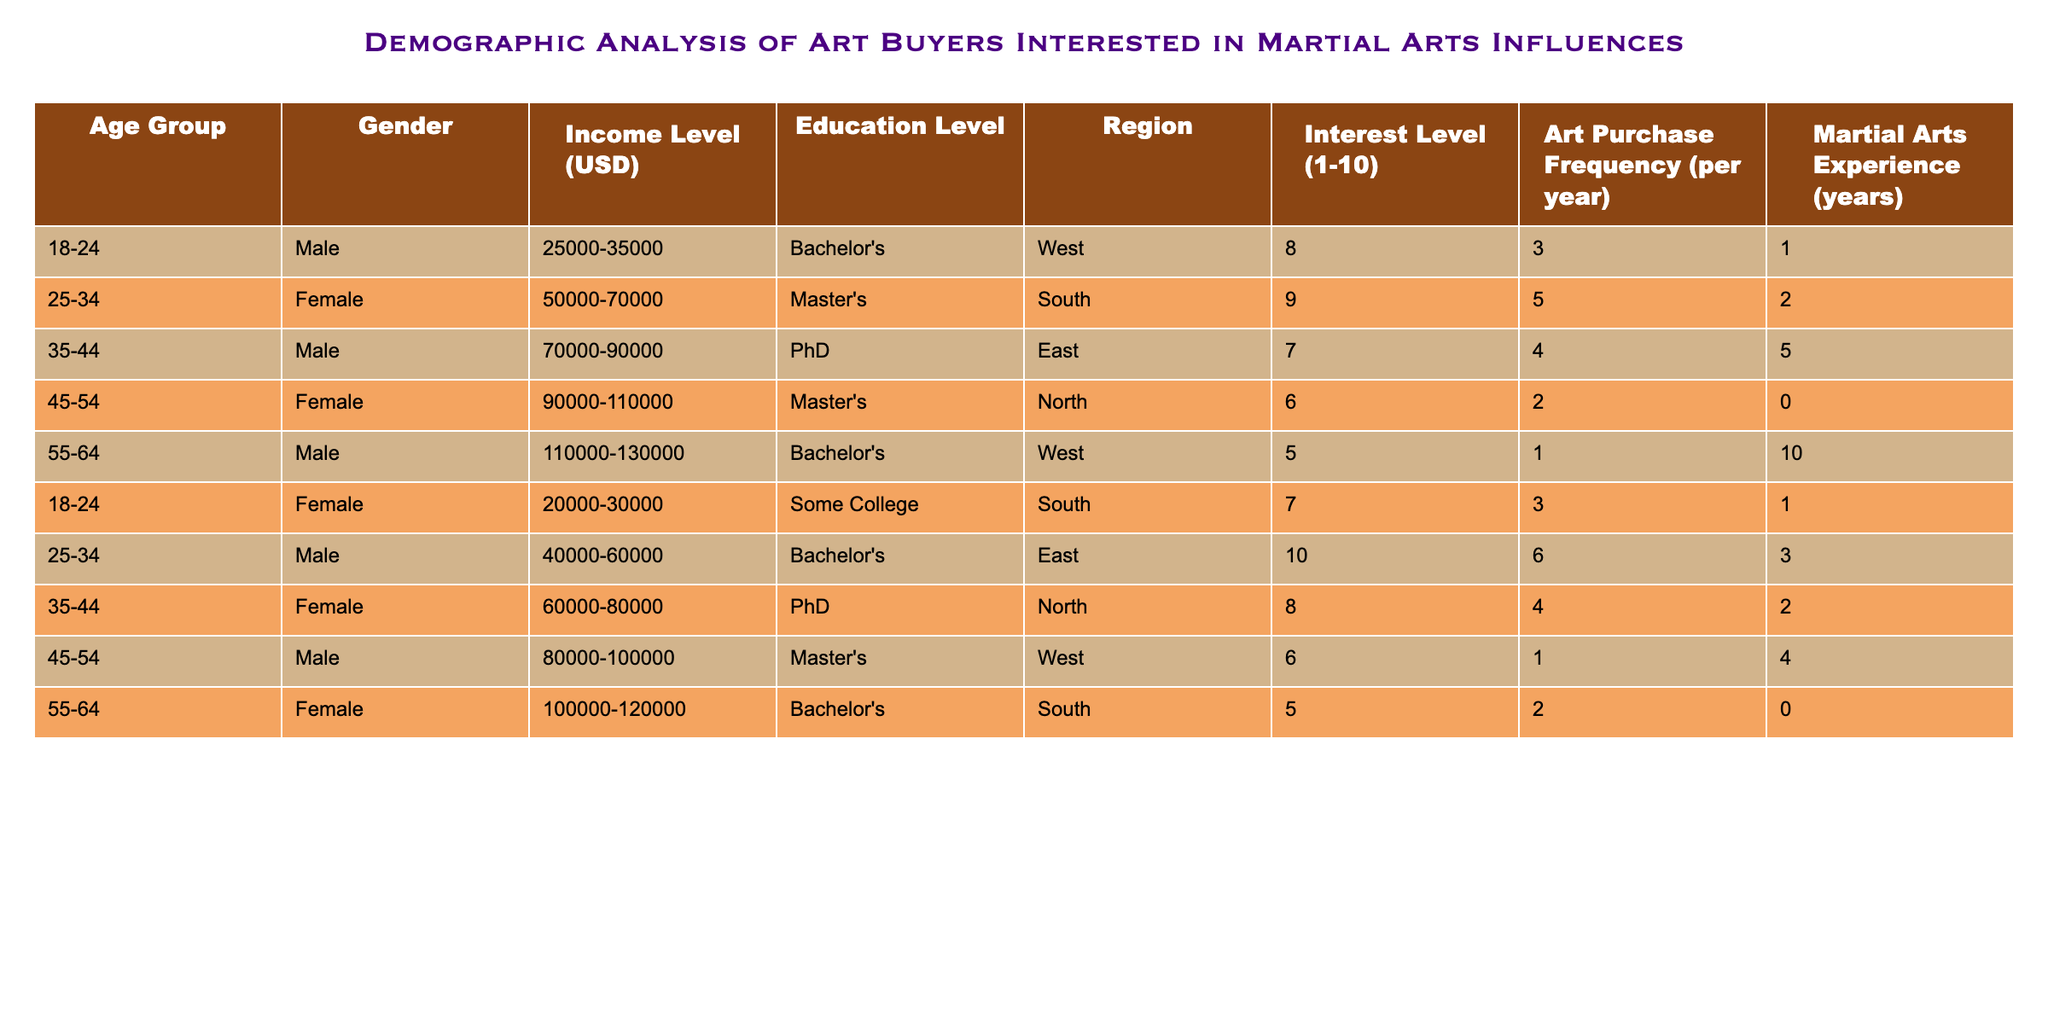What is the most common income level among art buyers? The income levels in the table show that there are several distinct ranges. By counting the occurrences of each income range, the most common one is 50000-70000, which appears twice among the art buyers.
Answer: 50000-70000 How many buyers have a martial arts experience of 2 years? By scanning the table, I identify individuals with 2 years of martial arts experience. There is one male in the age group 35-44 and one female in the age group 25-34, totaling two buyers.
Answer: 2 What is the average interest level of male art buyers? To calculate the average interest level of male buyers, first, identify all the male interest levels: 8, 7, 5, 10, and 6. The total is 36 (8+7+5+10+6) and there are 5 male buyers. Thus, the average is 36/5, which equals 7.2.
Answer: 7.2 Are there any female buyers with a PhD who have purchased art more than 4 times a year? Checking the table, I find two female buyers with PhD: one aged 35-44 (4 purchases) and the other aged 25-34 (5 purchases). None of them exceed 4 purchases. Therefore, the answer is no.
Answer: No Which age group has the highest average art purchase frequency? First, I need to calculate the average for each age group: 18-24 has averages of 3 and 3 (average = 3), 25-34 averages of 5 and 6 (average = 5.5), 35-44 averages of 4 and 4 (average = 4), 45-54 averages of 2 and 1 (average = 1.5), and 55-64 averages of 1 and 2 (average = 1.5). The highest average is from the 25-34 age group at 5.5.
Answer: 25-34 What percentage of buyers from the West region are interested at a level of 8 or higher? In the West region, there are 3 buyers: one male aged 55-64 with an interest level of 5, and two females aged 18-24 and 45-54 with interest levels of 8 and 6 respectively. Only the female aged 18-24 is at an interest level of 8 or higher. To find the percentage, divide 1 (the count of buyers with level 8 or higher) by 3 (total buyers from West) and multiply by 100, giving approximately 33.33%.
Answer: 33.33% How does the education level relate to the average income of buyers? Analyzing the education levels and income ranges for correlation, Bachelor's degrees had incomes spanning from 25000-35000 to 110000-130000, with varying representation. The lowest is 25000-35000 (Bachelor's, 18-24) and the highest is 110000-130000 (Bachelor's, 55-64). The average income for Bachelor's tends towards the higher bands given their span, while Master's and PhD have higher minimum income levels on average. Thus, there is a trend of higher education correlating with higher income levels.
Answer: Higher education correlates with higher income 